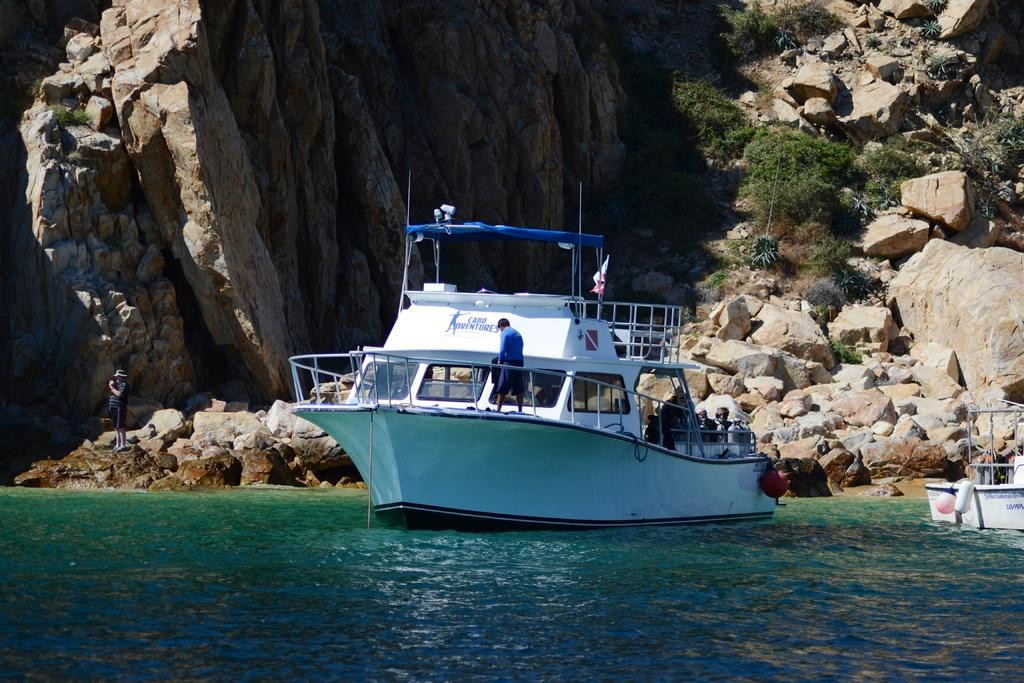<image>
Write a terse but informative summary of the picture. Large white ship in the waters which says CABO ADVENTURES. 